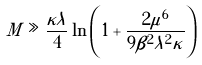Convert formula to latex. <formula><loc_0><loc_0><loc_500><loc_500>M \gg \frac { \kappa \lambda } { 4 } \ln \left ( 1 + \frac { 2 \mu ^ { 6 } } { 9 \beta ^ { 2 } \lambda ^ { 2 } \kappa } \right )</formula> 